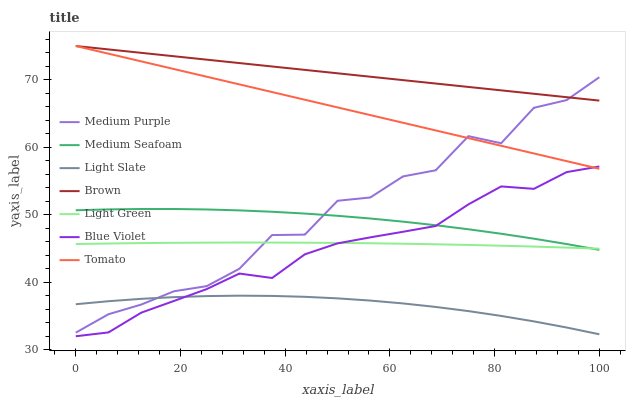Does Light Slate have the minimum area under the curve?
Answer yes or no. Yes. Does Brown have the maximum area under the curve?
Answer yes or no. Yes. Does Brown have the minimum area under the curve?
Answer yes or no. No. Does Light Slate have the maximum area under the curve?
Answer yes or no. No. Is Brown the smoothest?
Answer yes or no. Yes. Is Medium Purple the roughest?
Answer yes or no. Yes. Is Light Slate the smoothest?
Answer yes or no. No. Is Light Slate the roughest?
Answer yes or no. No. Does Blue Violet have the lowest value?
Answer yes or no. Yes. Does Light Slate have the lowest value?
Answer yes or no. No. Does Brown have the highest value?
Answer yes or no. Yes. Does Light Slate have the highest value?
Answer yes or no. No. Is Light Slate less than Brown?
Answer yes or no. Yes. Is Brown greater than Light Slate?
Answer yes or no. Yes. Does Medium Purple intersect Brown?
Answer yes or no. Yes. Is Medium Purple less than Brown?
Answer yes or no. No. Is Medium Purple greater than Brown?
Answer yes or no. No. Does Light Slate intersect Brown?
Answer yes or no. No. 